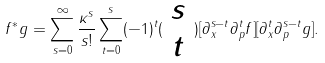<formula> <loc_0><loc_0><loc_500><loc_500>f ^ { * } g = \sum _ { s = 0 } ^ { \infty } \frac { \kappa ^ { s } } { s ! } \sum _ { t = 0 } ^ { s } ( - 1 ) ^ { t } ( \begin{array} { c } s \\ t \end{array} ) [ \partial _ { x } ^ { s - t } \partial _ { p } ^ { t } f ] [ \partial _ { x } ^ { t } \partial _ { p } ^ { s - t } g ] .</formula> 